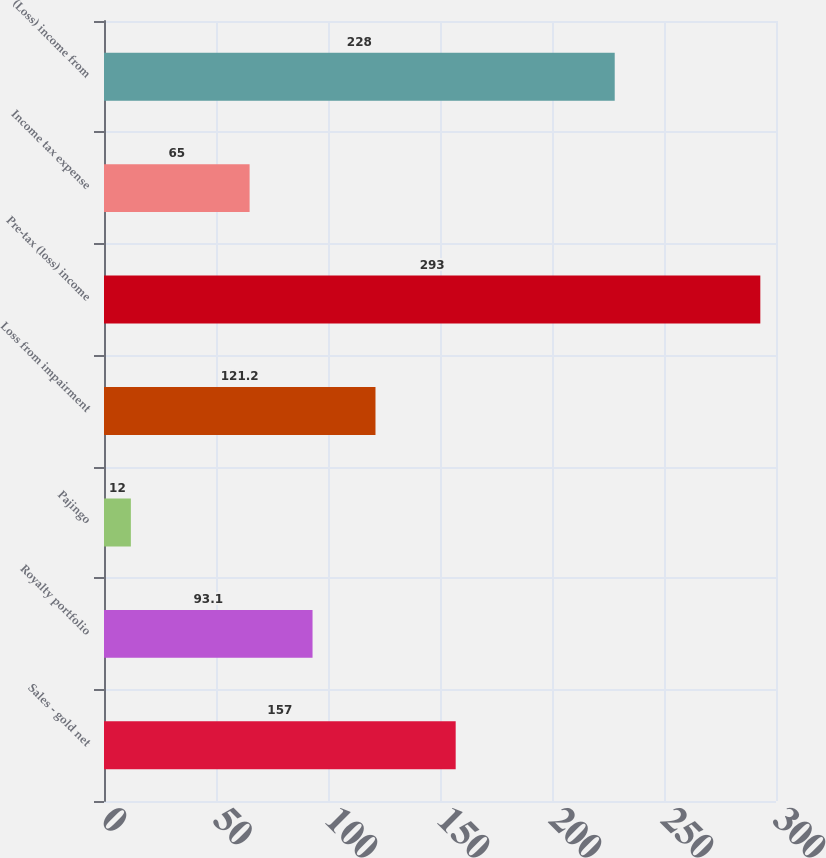<chart> <loc_0><loc_0><loc_500><loc_500><bar_chart><fcel>Sales - gold net<fcel>Royalty portfolio<fcel>Pajingo<fcel>Loss from impairment<fcel>Pre-tax (loss) income<fcel>Income tax expense<fcel>(Loss) income from<nl><fcel>157<fcel>93.1<fcel>12<fcel>121.2<fcel>293<fcel>65<fcel>228<nl></chart> 